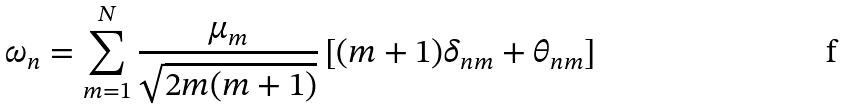Convert formula to latex. <formula><loc_0><loc_0><loc_500><loc_500>\omega _ { n } = \sum _ { m = 1 } ^ { N } \frac { \mu _ { m } } { \sqrt { 2 m ( m + 1 ) } } \left [ ( m + 1 ) \delta _ { n m } + \theta _ { n m } \right ]</formula> 